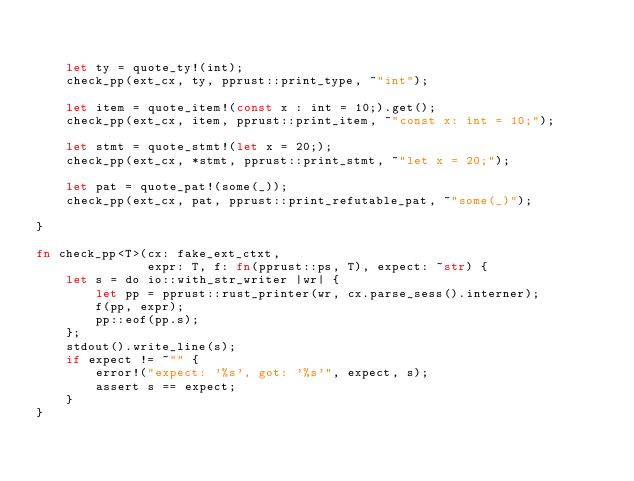Convert code to text. <code><loc_0><loc_0><loc_500><loc_500><_Rust_>

    let ty = quote_ty!(int);
    check_pp(ext_cx, ty, pprust::print_type, ~"int");

    let item = quote_item!(const x : int = 10;).get();
    check_pp(ext_cx, item, pprust::print_item, ~"const x: int = 10;");

    let stmt = quote_stmt!(let x = 20;);
    check_pp(ext_cx, *stmt, pprust::print_stmt, ~"let x = 20;");

    let pat = quote_pat!(some(_));
    check_pp(ext_cx, pat, pprust::print_refutable_pat, ~"some(_)");

}

fn check_pp<T>(cx: fake_ext_ctxt,
               expr: T, f: fn(pprust::ps, T), expect: ~str) {
    let s = do io::with_str_writer |wr| {
        let pp = pprust::rust_printer(wr, cx.parse_sess().interner);
        f(pp, expr);
        pp::eof(pp.s);
    };
    stdout().write_line(s);
    if expect != ~"" {
        error!("expect: '%s', got: '%s'", expect, s);
        assert s == expect;
    }
}

</code> 